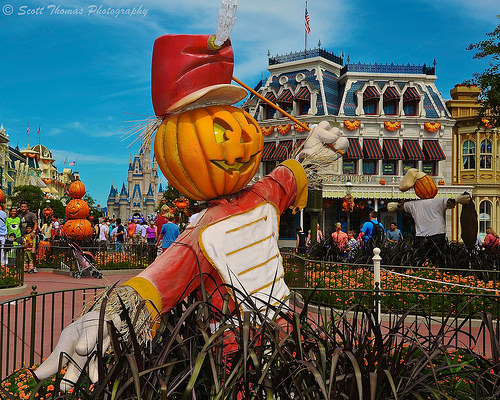<image>
Is there a pumpkin on the body? Yes. Looking at the image, I can see the pumpkin is positioned on top of the body, with the body providing support. 